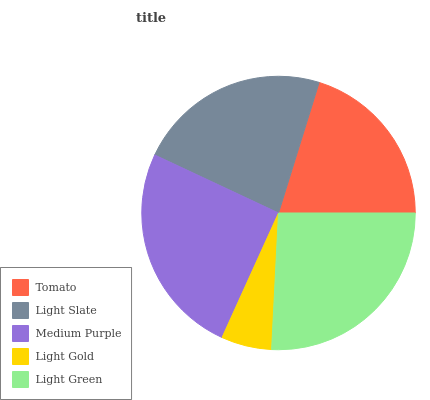Is Light Gold the minimum?
Answer yes or no. Yes. Is Light Green the maximum?
Answer yes or no. Yes. Is Light Slate the minimum?
Answer yes or no. No. Is Light Slate the maximum?
Answer yes or no. No. Is Light Slate greater than Tomato?
Answer yes or no. Yes. Is Tomato less than Light Slate?
Answer yes or no. Yes. Is Tomato greater than Light Slate?
Answer yes or no. No. Is Light Slate less than Tomato?
Answer yes or no. No. Is Light Slate the high median?
Answer yes or no. Yes. Is Light Slate the low median?
Answer yes or no. Yes. Is Tomato the high median?
Answer yes or no. No. Is Medium Purple the low median?
Answer yes or no. No. 